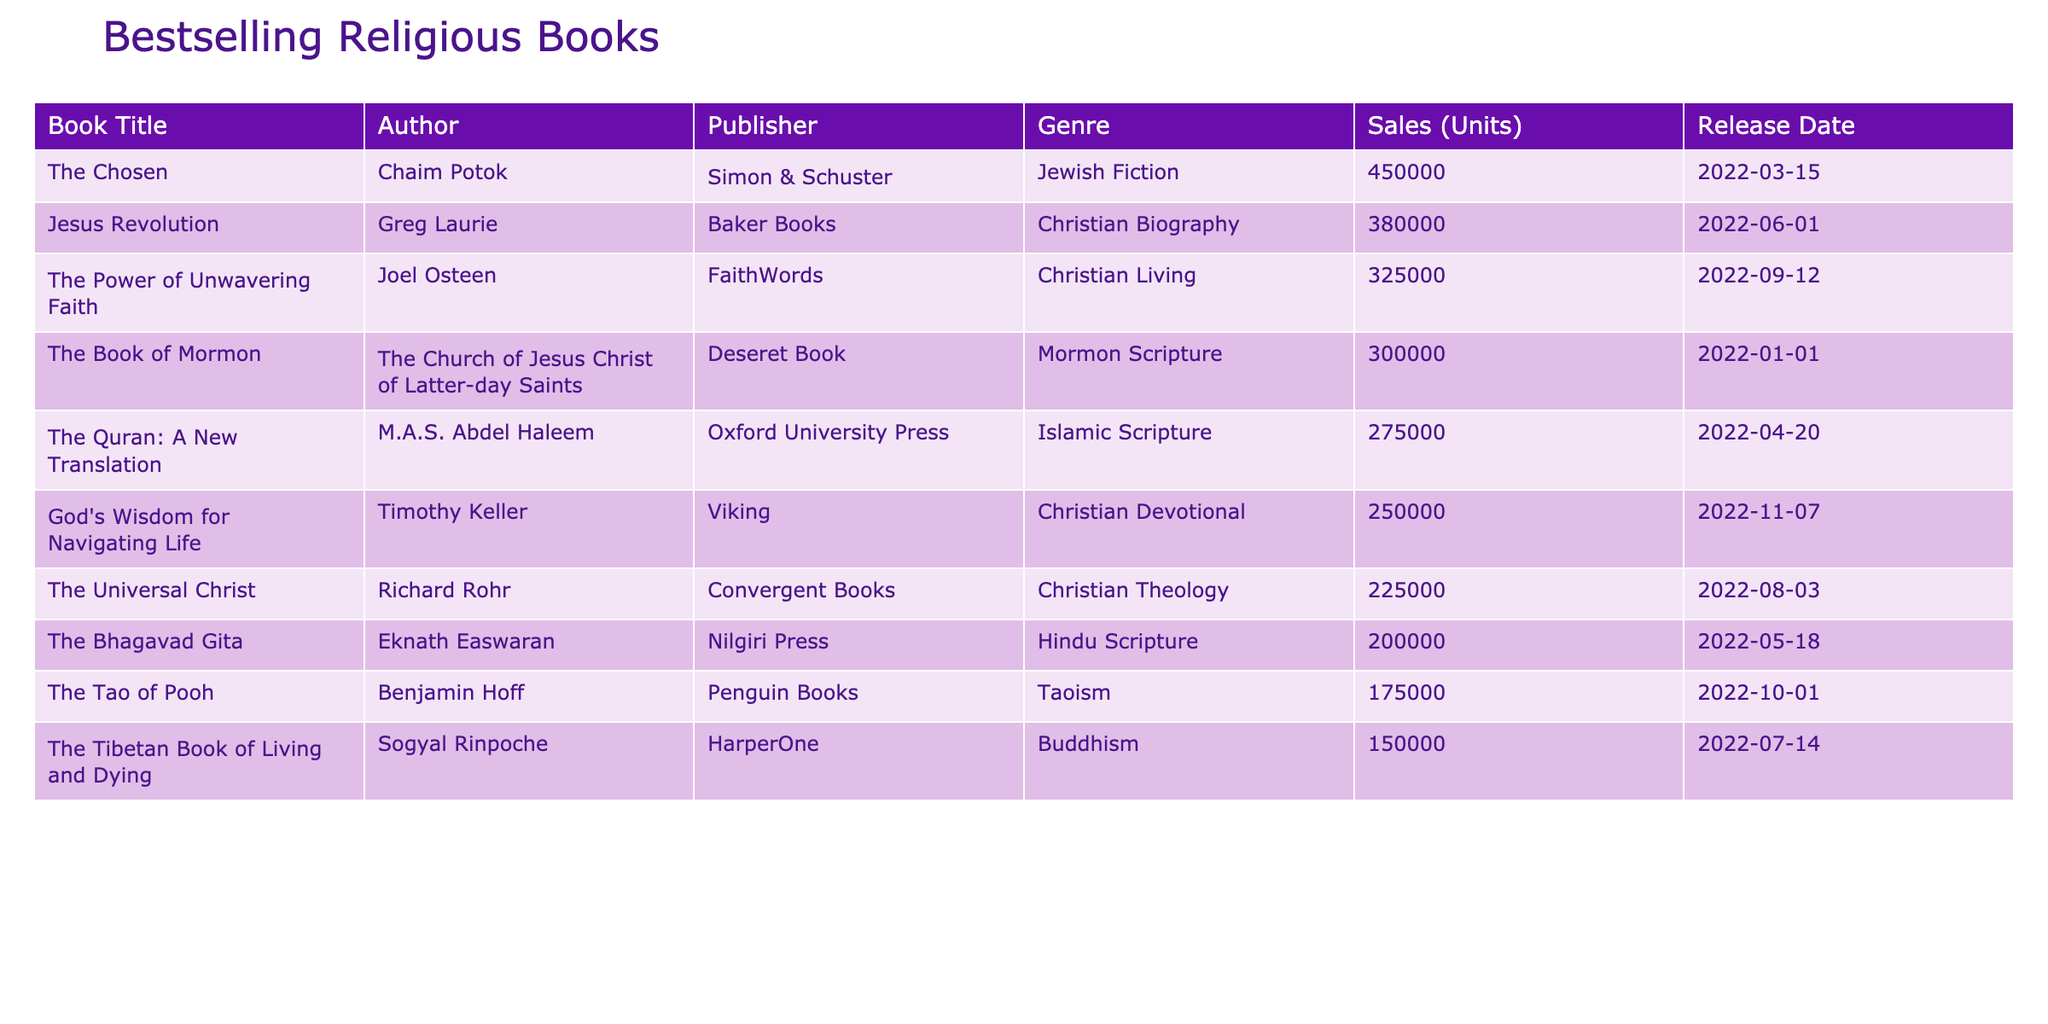What is the title of the bestselling religious book? The title of the bestselling religious book can be found in the first row of the table under the "Book Title" column. According to the data, "The Chosen" has the highest sales figures.
Answer: The Chosen Who is the author of "The Power of Unwavering Faith"? To find the author of "The Power of Unwavering Faith," we look in the "Author" column corresponding to that book title, which lists Joel Osteen as the author.
Answer: Joel Osteen How many units did "The Quran: A New Translation" sell? The sales figures for "The Quran: A New Translation" can be found in the "Sales (Units)" column next to the book title. It shows that it sold 275,000 units.
Answer: 275000 What percentage of "The Chosen" sales figure does "The Book of Mormon" represent? First, identify the sales figures: "The Chosen" sold 450,000 units and "The Book of Mormon" sold 300,000 units. Then, calculate the percentage: (300,000 / 450,000) * 100 = 66.67%.
Answer: 66.67% Is "The Tao of Pooh" more popular than "The Bhagavad Gita"? Compare the sales figures for both books: "The Tao of Pooh" sold 175,000 units, and "The Bhagavad Gita" sold 200,000 units. Since 175,000 is less than 200,000, "The Tao of Pooh" is not more popular.
Answer: No What is the average sales figure of the Christian Genre books listed? The Christian Genre books are "Jesus Revolution," "The Power of Unwavering Faith," "God's Wisdom for Navigating Life," "The Universal Christ," totaling sales of 380,000, 325,000, 250,000, and 225,000 respectively. First, add these figures: (380,000 + 325,000 + 250,000 + 225,000) = 1,180,000. Then divide by the number of books (4): 1,180,000 / 4 = 295,000.
Answer: 295000 Which book has the lowest sales figure and who is its author? To find this, review the "Sales (Units)" column to identify the lowest sales, which is 150,000 for "The Tibetan Book of Living and Dying." The corresponding author from the "Author" column is Sogyal Rinpoche.
Answer: Sogyal Rinpoche What is the total sales figure of all books combined? To find the total sales figure, sum all the values in the "Sales (Units)" column: 450000 + 380000 + 325000 + 300000 + 275000 + 250000 + 225000 + 200000 + 175000 + 150000 = 2,730,000.
Answer: 2730000 If the sales of "The Chosen" and "The Gospel According to Jesus" (which didn't make the list) were combined, would their total sales exceed "Jesus Revolution"? Since "The Gospel According to Jesus" is not in the list, we only consider "The Chosen," which has 450,000 units. Compare it to "Jesus Revolution" which has 380,000 units. 450,000 is certainly more than 380,000.
Answer: Yes Which two genres have the highest combined sales figures? Calculate total sales per genre: for Christian (1,180,000), Jewish (450,000), and Islam (275,000). Christian (1,180,000) and Jewish (450,000) provides the highest combined sales: 1,630,000, surpassing others.
Answer: Christian and Jewish 